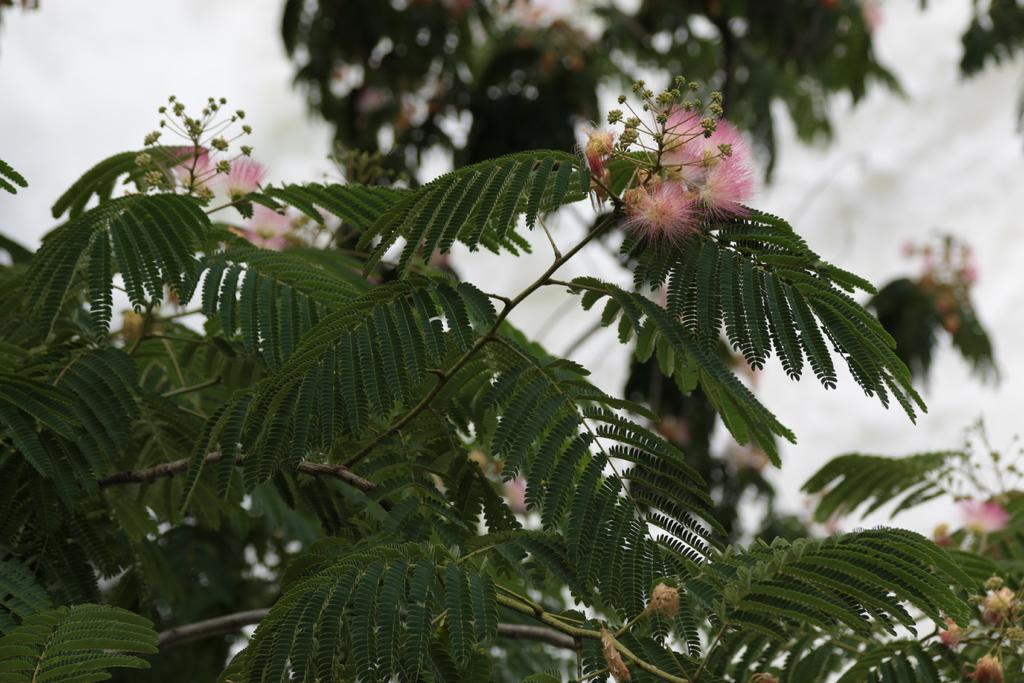What is present in the image? There is a plant in the image. What specific feature of the plant can be observed? The plant has flowers. What color are the flowers? The flowers are pink. What can be seen in the background of the image? There is a tree and the sky visible in the background of the image. How is the background of the image depicted? The background is blurred. What time is displayed on the clock in the image? There is no clock present in the image. What type of shade is covering the plant in the image? There is no shade covering the plant in the image. 